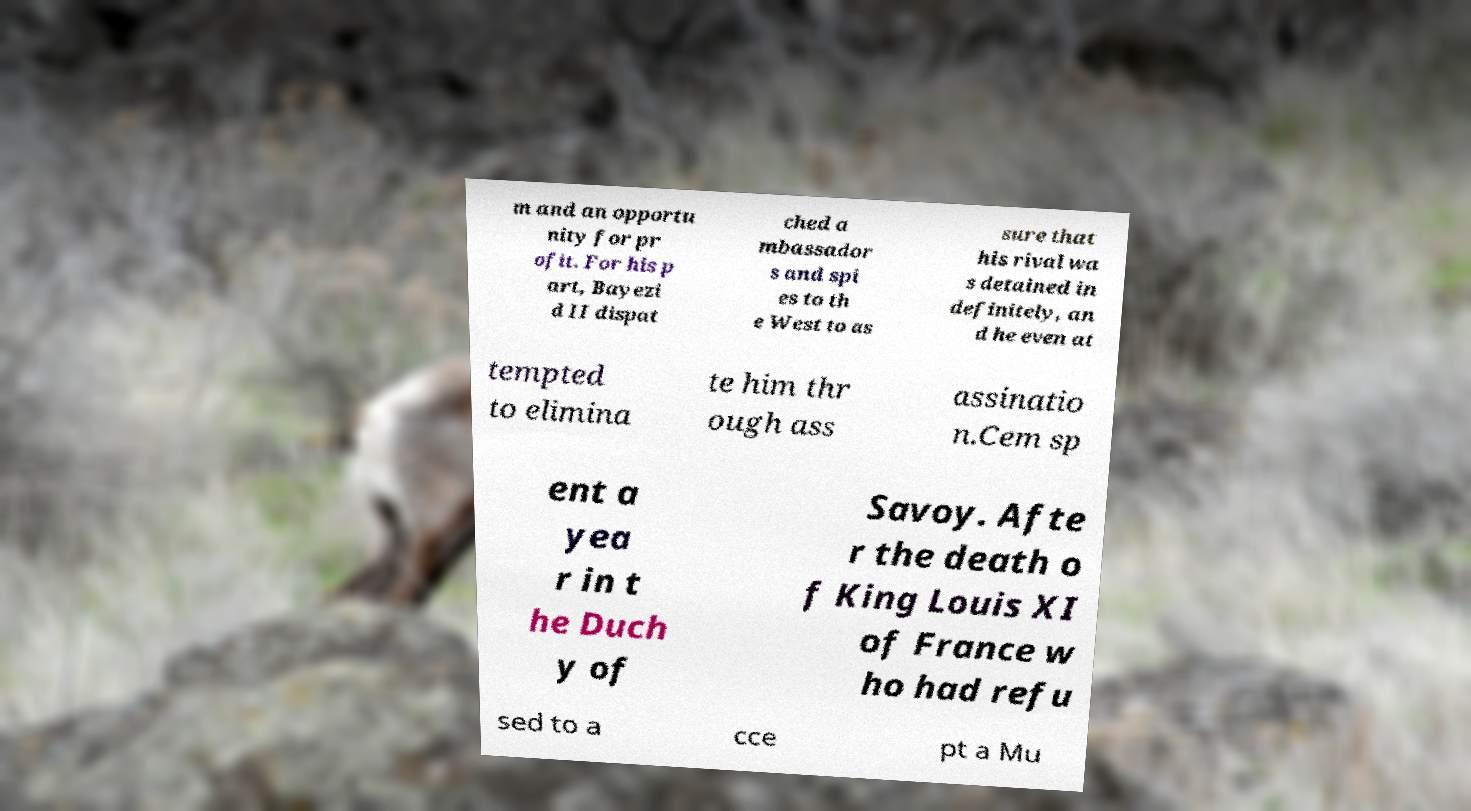Please identify and transcribe the text found in this image. m and an opportu nity for pr ofit. For his p art, Bayezi d II dispat ched a mbassador s and spi es to th e West to as sure that his rival wa s detained in definitely, an d he even at tempted to elimina te him thr ough ass assinatio n.Cem sp ent a yea r in t he Duch y of Savoy. Afte r the death o f King Louis XI of France w ho had refu sed to a cce pt a Mu 